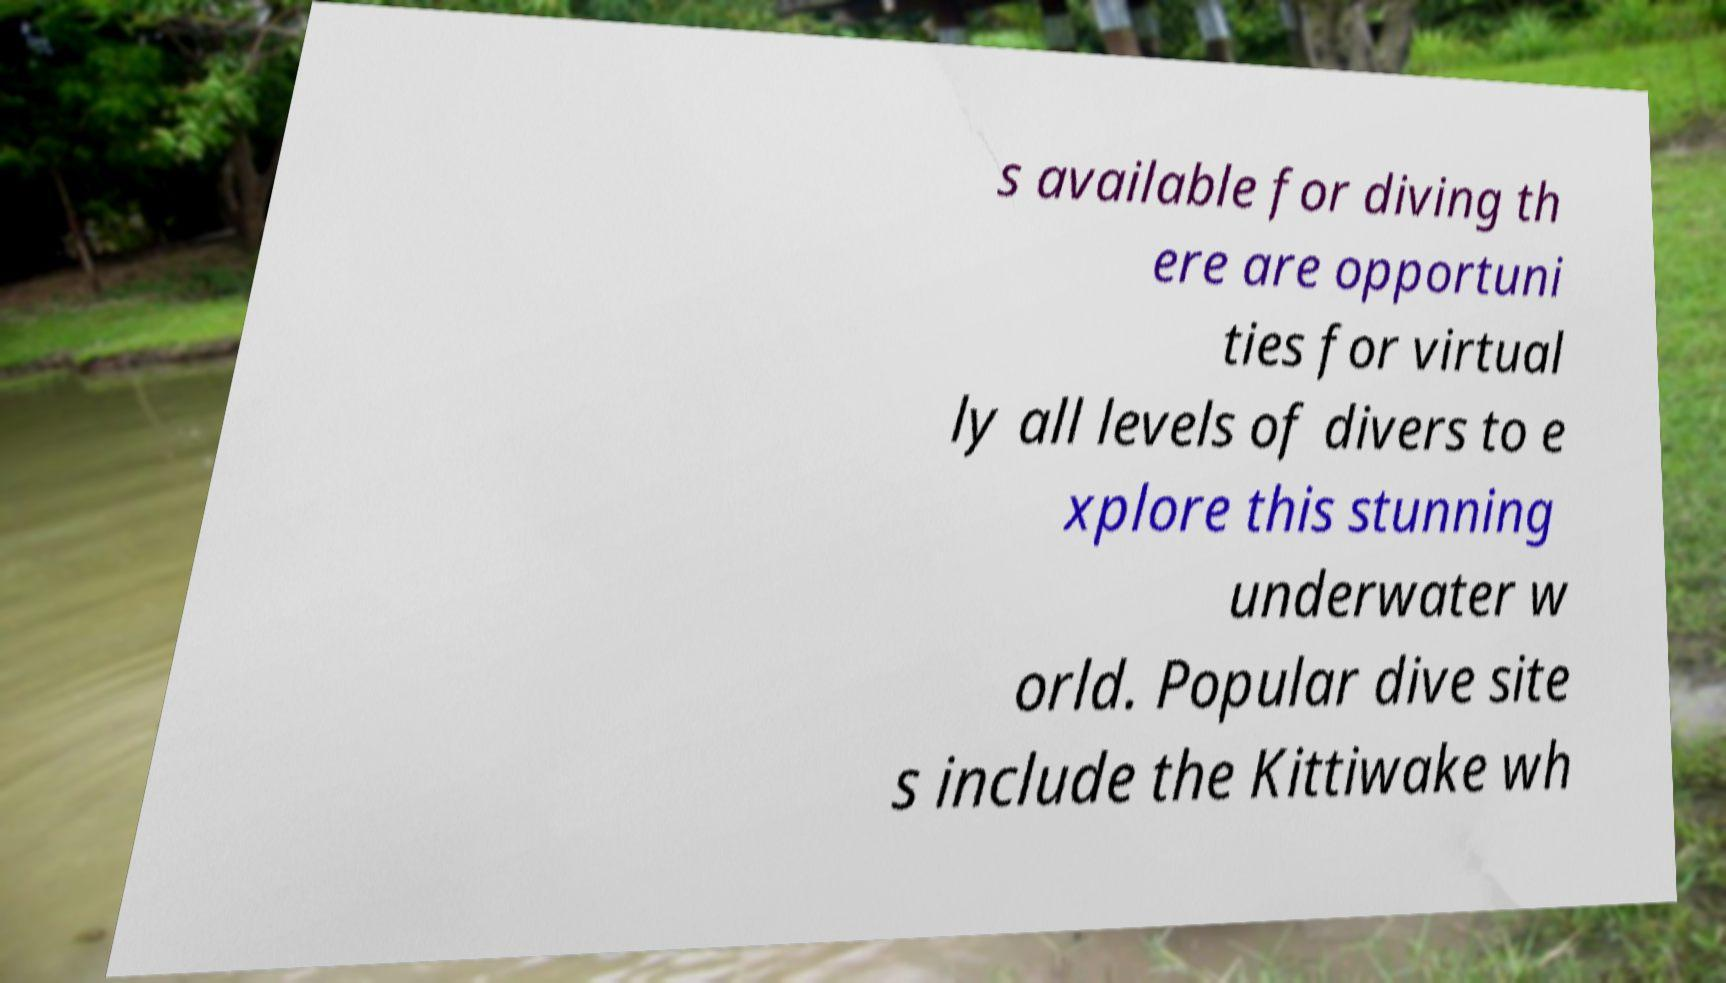Could you assist in decoding the text presented in this image and type it out clearly? s available for diving th ere are opportuni ties for virtual ly all levels of divers to e xplore this stunning underwater w orld. Popular dive site s include the Kittiwake wh 